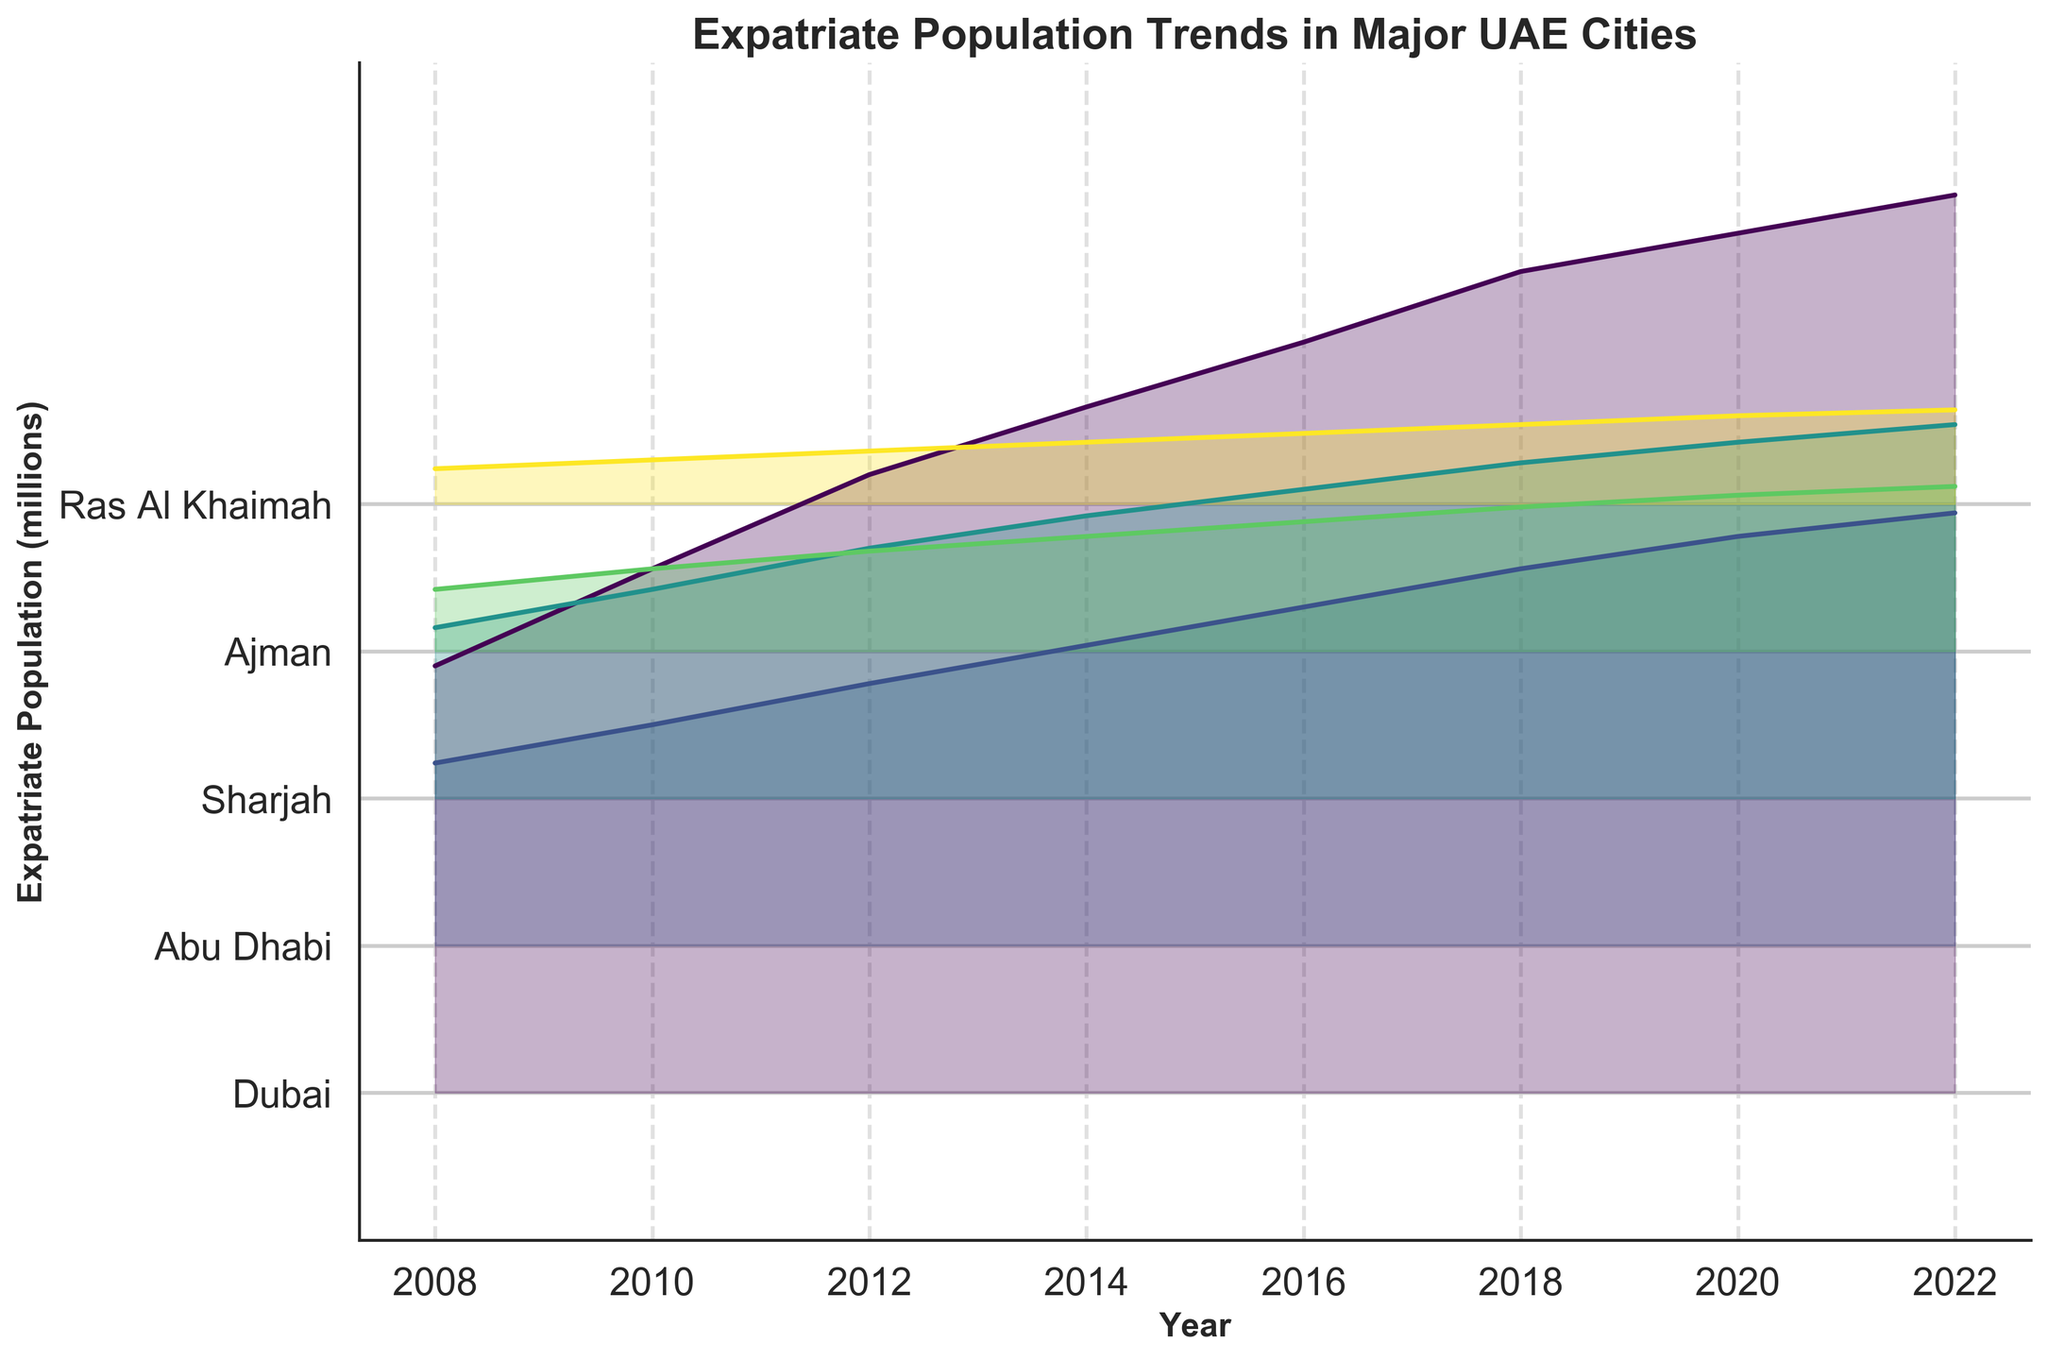What's the title of the figure? The title of the figure is usually placed at the top. In this Ridgeline plot, it clearly reads "Expatriate Population Trends in Major UAE Cities".
Answer: Expatriate Population Trends in Major UAE Cities Which city had the highest expatriate population in 2022? To find the city with the highest expatriate population in 2022, we look at the topmost line in the Ridgeline plot for the year 2022. Dubai is at the top with the highest value.
Answer: Dubai How did the expatriate population trend for Abu Dhabi change from 2008 to 2022? To see the trend, trace the line corresponding to Abu Dhabi from 2008 to 2022. The line shows a steady increase from 0.62 million in 2008 to 1.47 million in 2022.
Answer: Steady increase Compare the expatriate population in Sharjah and Ajman in 2014. Which city had more expats? Find the lines corresponding to Sharjah and Ajman for the year 2014. Sharjah's population is higher than Ajman's, with values of 0.96 million and 0.39 million, respectively.
Answer: Sharjah What's the average expatriate population in Ajman between 2008 and 2022? First, sum the values for Ajman from 2008 to 2022: 0.21 + 0.28 + 0.34 + 0.39 + 0.44 + 0.49 + 0.53 + 0.56 = 3.24 million. There are 8 data points, so the average is 3.24 / 8.
Answer: 0.405 million What is the general trend in expatriate populations across all cities from 2008 to 2022? By examining all lines from left (2008) to right (2022), we can observe that all cities show an increasing trend in expatriate populations over time.
Answer: Increasing trend How much did the expatriate population of Ras Al Khaimah grow from 2010 to 2022? The population in Ras Al Khaimah in 2010 was 0.15 million and 0.32 million in 2022. The growth can be calculated as 0.32 - 0.15 = 0.17 million.
Answer: 0.17 million Identify the city with the least noticeable growth in expatriate population from 2008 to 2022. The city with the relatively smallest change over the years can be identified by comparing the vertical shifts in the baseline. Ras Al Khaimah shows the least growth, increasing from 0.12 million in 2008 to 0.32 million in 2022.
Answer: Ras Al Khaimah Which year shows the highest number of expatriates in Dubai, and how many were there? The year with the highest number is at the far right end for Dubai. In 2022, Dubai's expatriate population reached 3.05 million.
Answer: 2022, 3.05 million What was the difference in expatriate populations between Sharjah and Abu Dhabi in 2016? For 2016, Sharjah had 1.05 million, and Abu Dhabi had 1.15 million. The difference is 1.15 - 1.05 = 0.10 million.
Answer: 0.10 million 